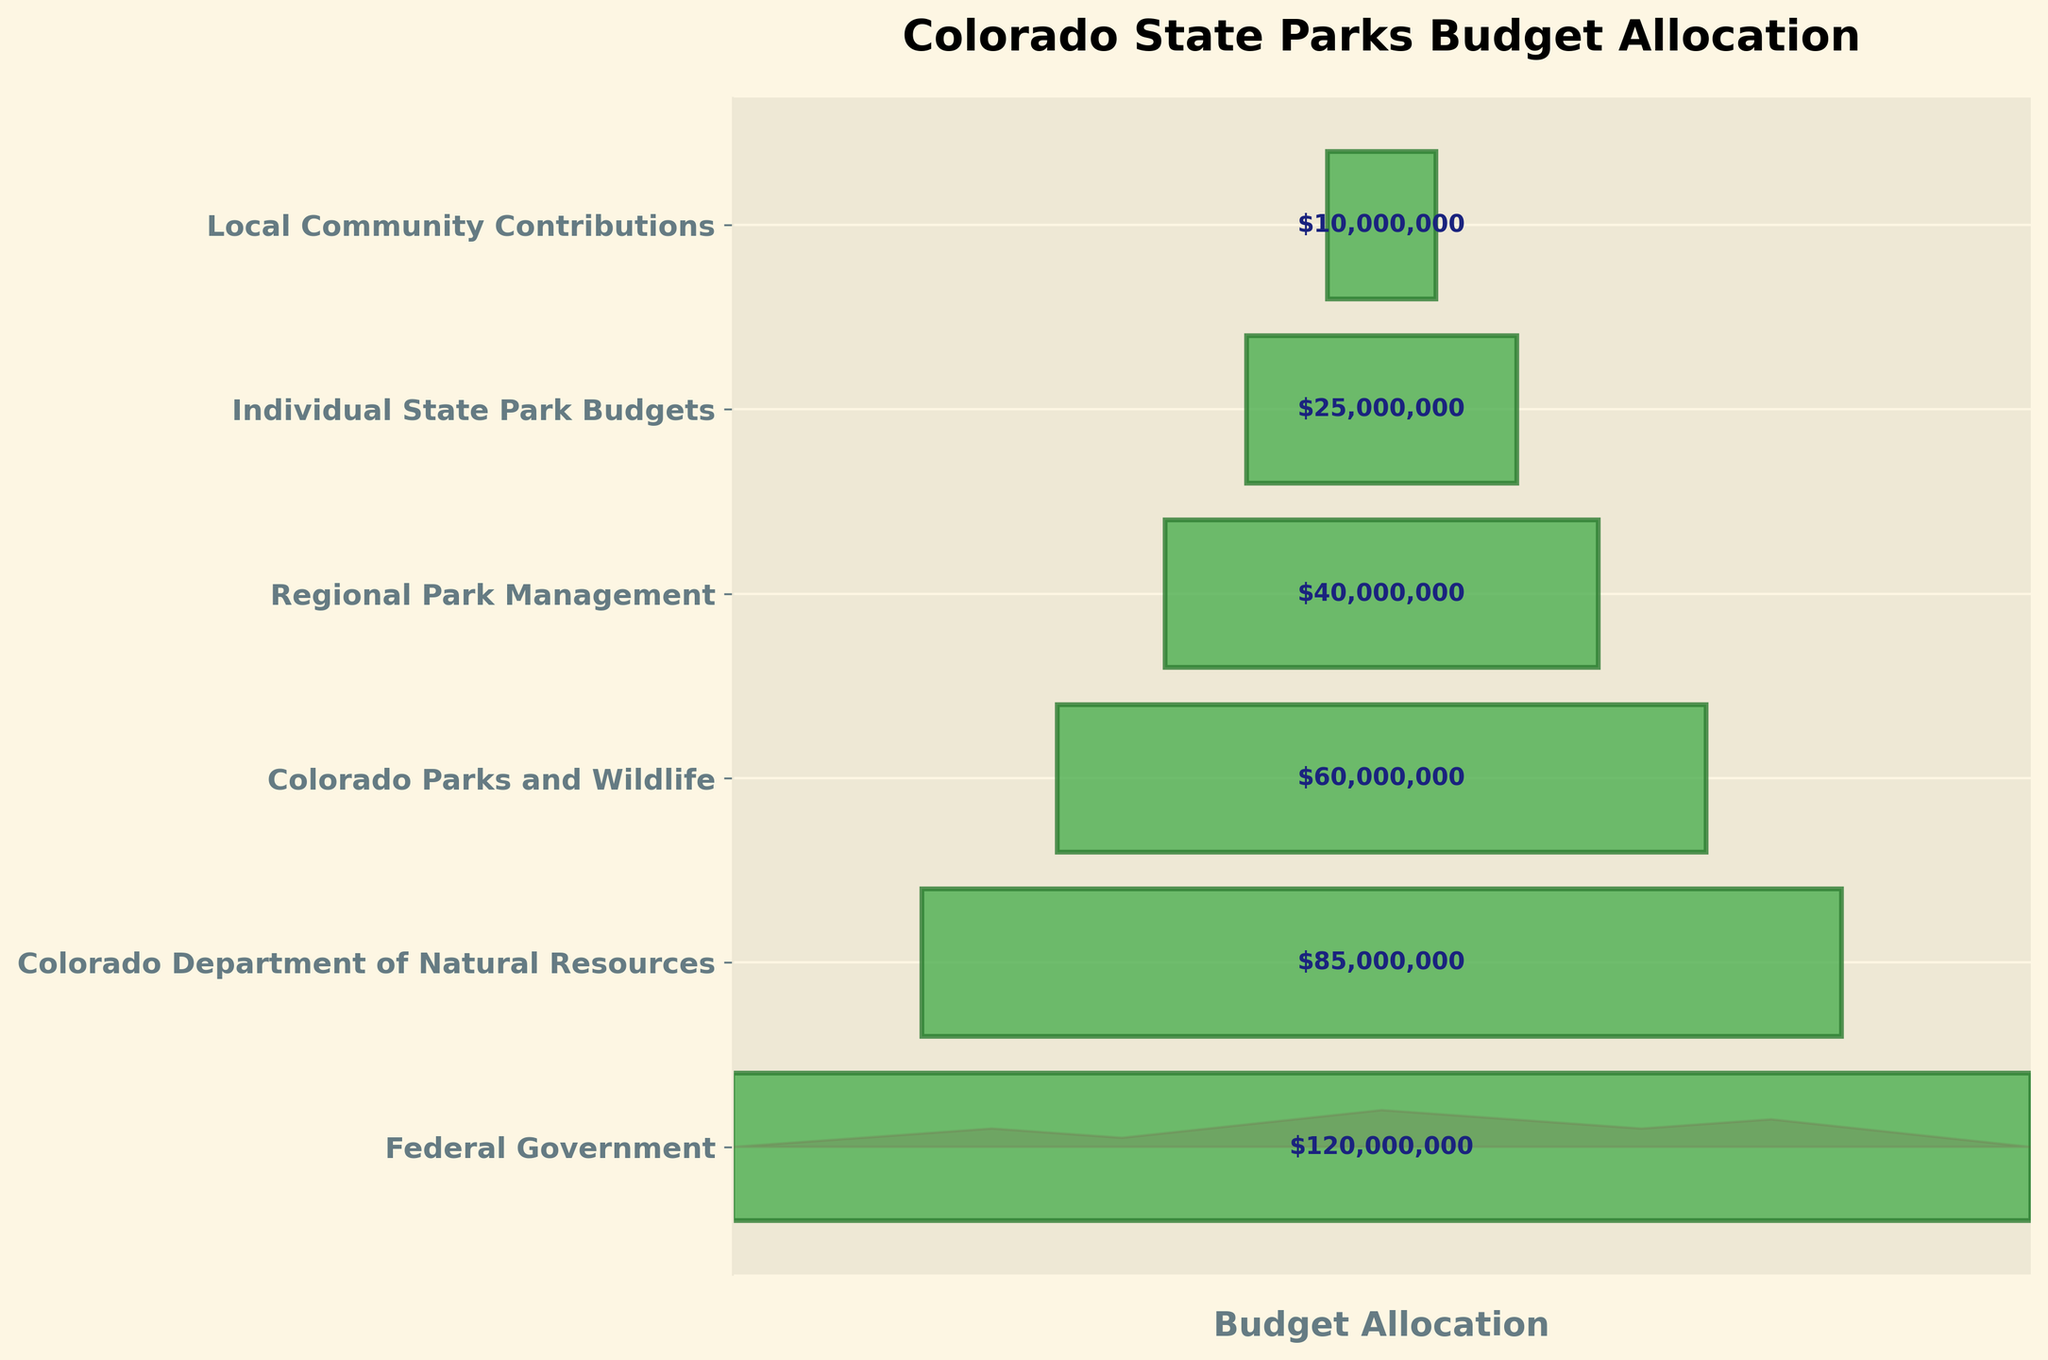What is the title of the funnel chart? The title of the funnel chart is displayed at the top of the figure, which reads "Colorado State Parks Budget Allocation".
Answer: Colorado State Parks Budget Allocation How many levels of budget allocation are shown in the funnel chart? The figure shows different horizontal bars, each representing a distinct level. By counting these bars, we can determine that there are six levels shown in the chart.
Answer: 6 Which level has the highest budget allocation? To determine this, look at the widest bar in the funnel chart, which is located at the top. This bar represents the Federal Government, indicating that it has the highest budget allocation.
Answer: Federal Government What is the total budget allocation for all levels combined? Sum the budget allocations from each level: $120,000,000 (Federal) + $85,000,000 (Colorado Department of Natural Resources) + $60,000,000 (Colorado Parks and Wildlife) + $40,000,000 (Regional Park Management) + $25,000,000 (Individual State Park Budgets) + $10,000,000 (Local Community Contributions). The total is $340,000,000.
Answer: $340,000,000 How does the budget allocation for Regional Park Management compare to that of Individual State Park Budgets? Compare the budget values directly. Regional Park Management has an allocation of $40,000,000, while Individual State Park Budgets have $25,000,000. Therefore, Regional Park Management has a higher budget.
Answer: Regional Park Management has a higher budget What proportion of the total budget is allocated to Colorado Parks and Wildlife? First, calculate the total budget as $340,000,000. The budget for Colorado Parks and Wildlife is $60,000,000. The proportion is $60,000,000 / $340,000,000 ≈ 0.176, or about 17.6%.
Answer: Approximately 17.6% What is the difference in budget allocation between the Federal Government and Local Community Contributions? Subtract the budget of Local Community Contributions ($10,000,000) from that of the Federal Government ($120,000,000). The difference is $120,000,000 - $10,000,000 = $110,000,000.
Answer: $110,000,000 Which level has the second smallest budget allocation, and what is its value? Arrange the budget allocations from smallest to largest: $10,000,000, $25,000,000, $40,000,000, $60,000,000, $85,000,000, $120,000,000. The second smallest allocation is $25,000,000, which corresponds to Individual State Park Budgets.
Answer: Individual State Park Budgets, $25,000,000 If the budget allocation for Colorado Parks and Wildlife were to increase by $10,000,000, what would the new budget be and how would it compare to the Colorado Department of Natural Resources? The current budget for Colorado Parks and Wildlife is $60,000,000. An increase of $10,000,000 results in $60,000,000 + $10,000,000 = $70,000,000. Comparing this to the Colorado Department of Natural Resources, which is $85,000,000, Colorado Parks and Wildlife would still have a lower budget.
Answer: $70,000,000, still lower than Colorado Department of Natural Resources 